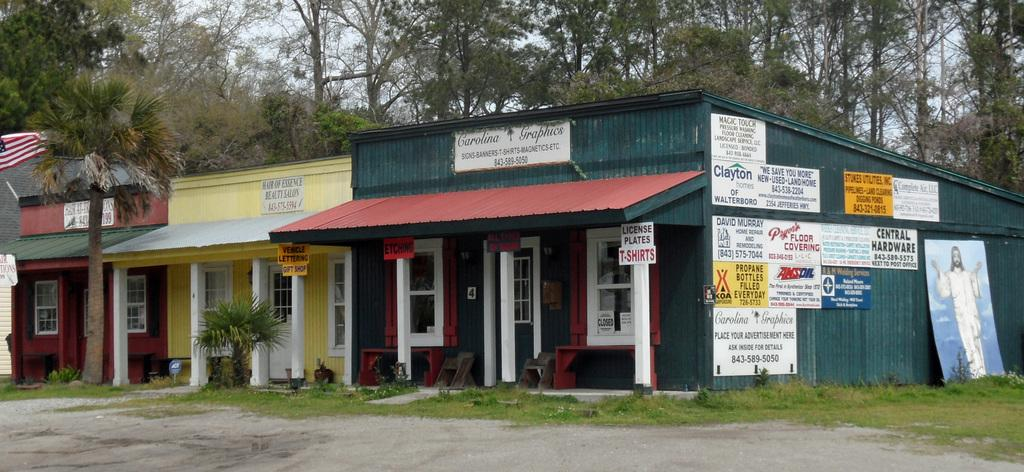What type of structures can be seen in the image? There are buildings in the image. What objects are present in the image that might be used for displaying information or advertisements? There are boards in the image. What type of vegetation is visible in the image? There are plants and grass in the image. What is attached to the flag in the image? There is a flag with a pole in the image. What can be seen in the background of the image? There are trees and the sky visible in the background of the image. How does the wren interact with the flag in the image? There is no wren present in the image, so it cannot interact with the flag. 